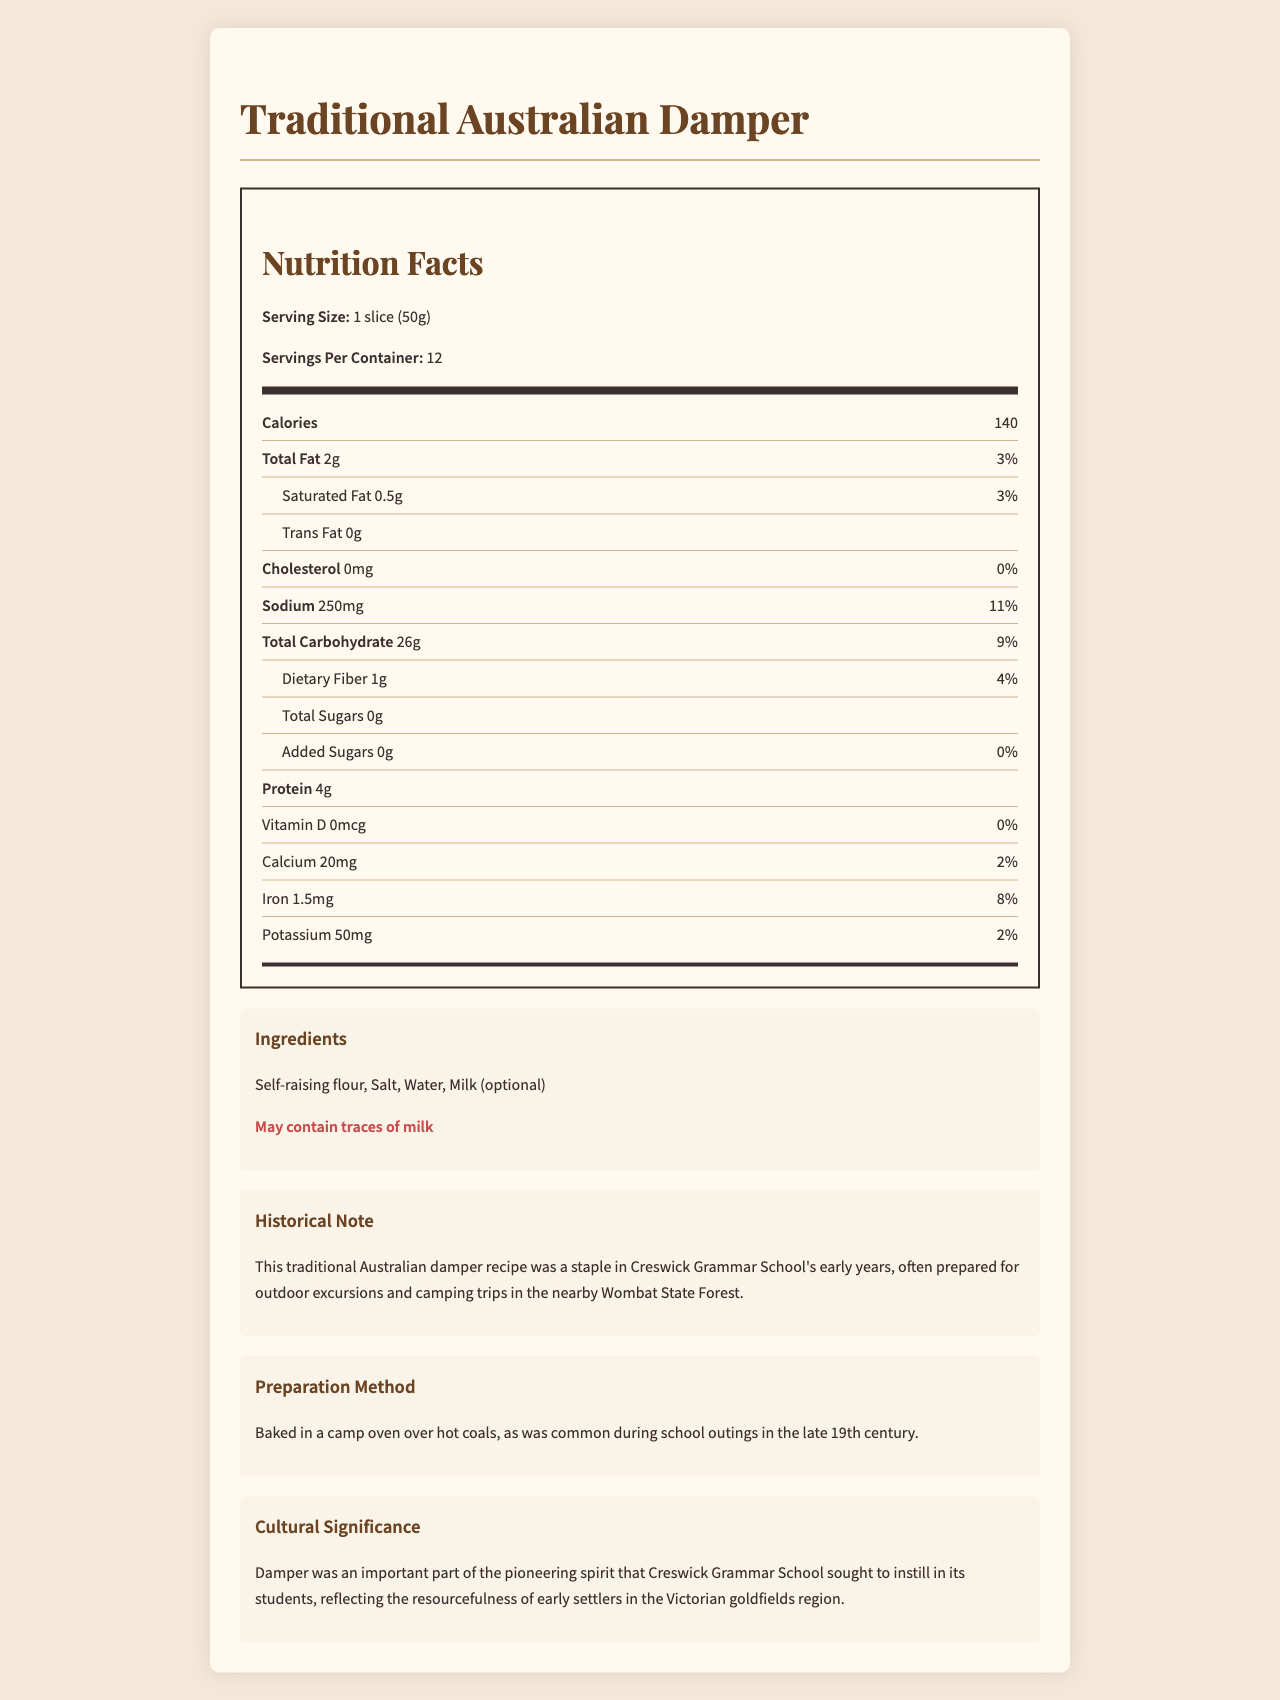what is the serving size of the traditional damper? The serving size is explicitly mentioned as "1 slice (50g)" in the document.
Answer: 1 slice (50g) how many calories are in one serving of the damper? The nutrition label lists "Calories: 140" under the nutrition facts.
Answer: 140 calories how much sodium does each serving contain? According to the nutrition facts section, each serving contains 250mg of sodium.
Answer: 250mg what is the percentage of daily value for protein per serving? The document provides the amount of protein (4g) but does not specify the daily value percentage for it.
Answer: Not specified name three ingredients mentioned in the damper recipe. The ingredients section lists self-raising flour, salt, water, and optional milk.
Answer: Self-raising flour, Salt, Water what is the daily value percentage of iron in the damper? The nutrition facts specify that each serving contains 8% of the daily value for iron.
Answer: 8% how is the traditional damper prepared during school outings? The document states that the damper was baked in a camp oven over hot coals.
Answer: Baked in a camp oven over hot coals does the damper contain any trans fat? (Yes/No) The nutrition facts indicate "Trans Fat: 0g," meaning it contains no trans fat.
Answer: No are there any added sugars in the damper? The document mentions there are 0g of added sugars in the damper.
Answer: No what is the main cultural significance of the damper for Creswick Grammar School students? The cultural significance section explains that the damper reflects the pioneering spirit and resourcefulness encouraged in the students.
Answer: Reflects the pioneering spirit and resourcefulness of early settlers in the Victorian goldfields region how much calcium is there per serving, and what percentage of daily value does this represent? Each serving contains 20mg of calcium, which represents 2% of the daily value.
Answer: 20mg, 2% how many servings are in one container of the damper? A. 8 B. 10 C. 12 The label states "Servings Per Container: 12".
Answer: C. 12 which ingredient might potentially cause an allergic reaction? A. Self-raising flour B. Salt C. Milk The allergen warning notes that the damper may contain traces of milk.
Answer: C. Milk does the damper contain any dietary fiber? (Yes/No) The nutrition facts indicate that each serving contains 1g of dietary fiber.
Answer: Yes what is the total amount of carbohydrates in one serving of the damper? According to the nutrition facts, each serving contains 26g of total carbohydrates.
Answer: 26g summarize the document, mentioning its primary contents. The document is a comprehensive nutrition label for traditional Australian damper, providing both nutritional information and historical context relevant to Creswick Grammar School.
Answer: The document provides detailed nutrition facts for a traditional Australian damper recipe, including serving size, calories, amounts of fat, cholesterol, sodium, carbohydrates, fiber, sugars, protein, and various vitamins and minerals. It lists the ingredients, mentions an allergen warning for milk, and describes its historical significance, preparation methods, and cultural significance for Creswick Grammar School. what was the main purpose of Creswick Grammar School's damper recipe? The document does not explicitly state the primary purpose beyond its historical preparation and cultural significance.
Answer: Not enough information how much daily value percentage of vitamin D is in each serving? The nutrition facts specify 0mcg of vitamin D, which is 0% of the daily value.
Answer: 0% 